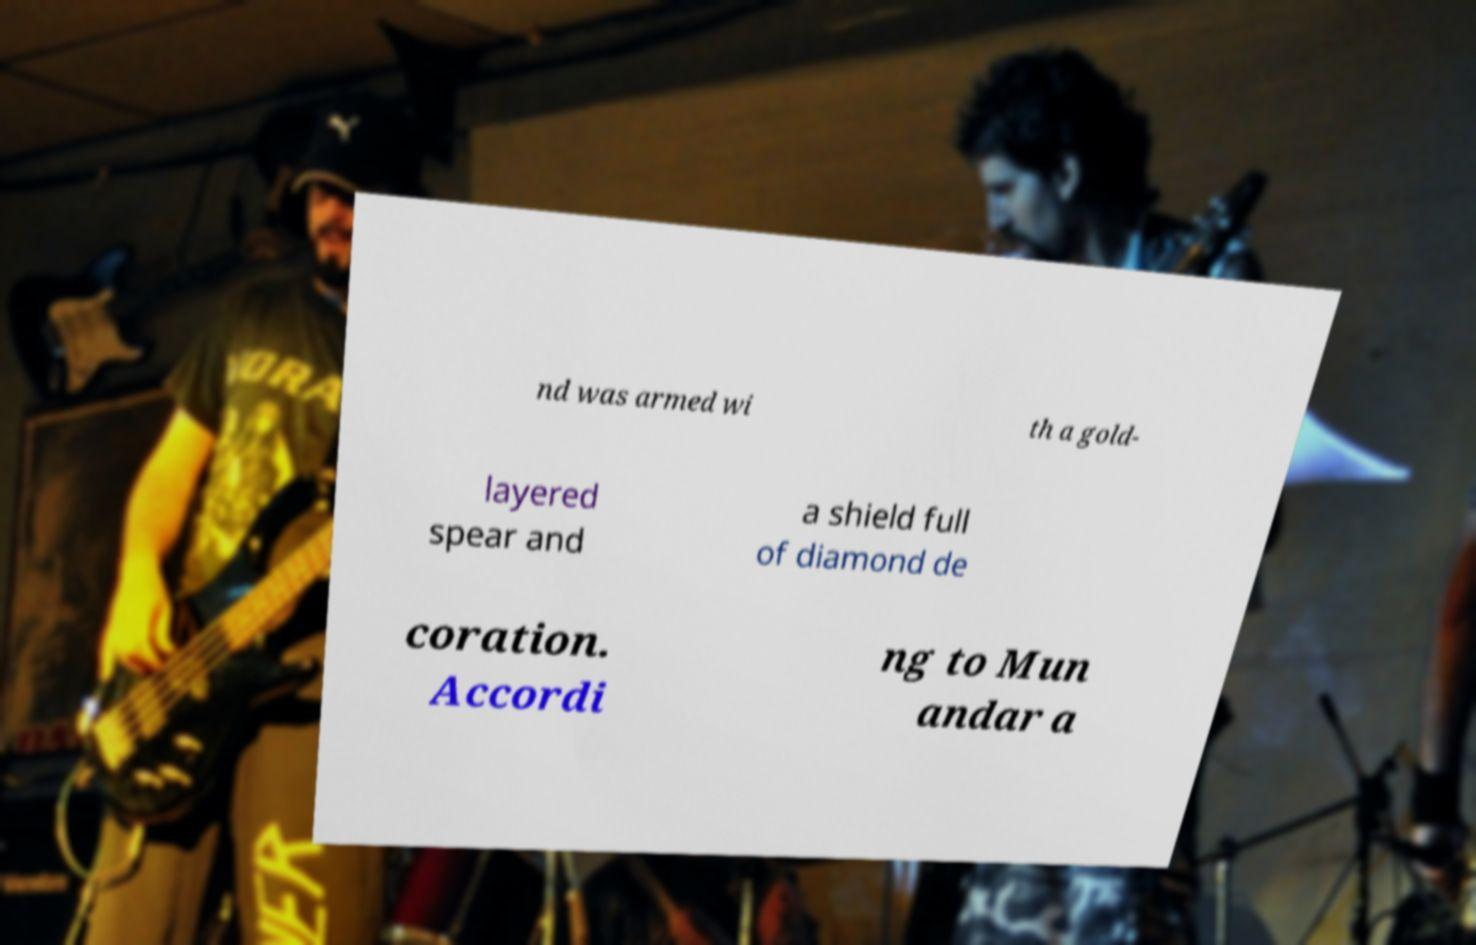Please identify and transcribe the text found in this image. nd was armed wi th a gold- layered spear and a shield full of diamond de coration. Accordi ng to Mun andar a 